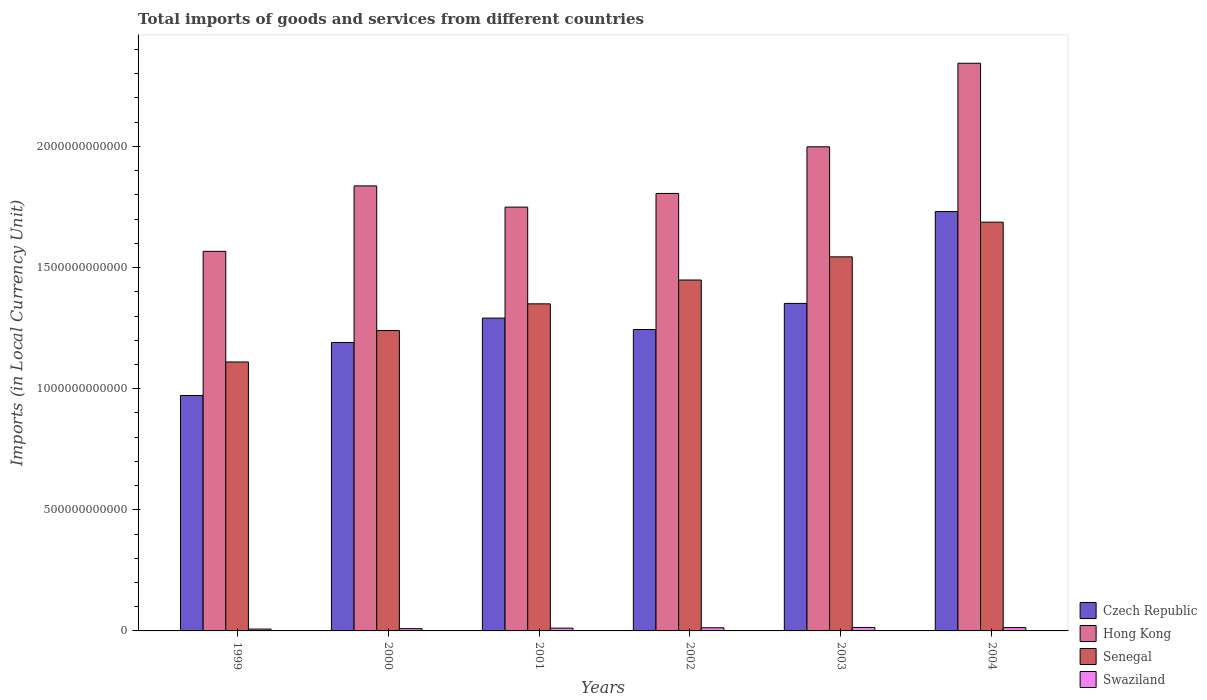How many groups of bars are there?
Your answer should be very brief. 6. Are the number of bars on each tick of the X-axis equal?
Provide a succinct answer. Yes. How many bars are there on the 3rd tick from the left?
Your answer should be very brief. 4. What is the label of the 6th group of bars from the left?
Provide a short and direct response. 2004. What is the Amount of goods and services imports in Czech Republic in 2004?
Provide a short and direct response. 1.73e+12. Across all years, what is the maximum Amount of goods and services imports in Czech Republic?
Keep it short and to the point. 1.73e+12. Across all years, what is the minimum Amount of goods and services imports in Swaziland?
Your answer should be very brief. 7.69e+09. In which year was the Amount of goods and services imports in Senegal minimum?
Make the answer very short. 1999. What is the total Amount of goods and services imports in Czech Republic in the graph?
Make the answer very short. 7.78e+12. What is the difference between the Amount of goods and services imports in Swaziland in 2002 and that in 2003?
Offer a very short reply. -1.25e+09. What is the difference between the Amount of goods and services imports in Senegal in 2000 and the Amount of goods and services imports in Hong Kong in 2002?
Provide a succinct answer. -5.66e+11. What is the average Amount of goods and services imports in Swaziland per year?
Your answer should be very brief. 1.16e+1. In the year 1999, what is the difference between the Amount of goods and services imports in Senegal and Amount of goods and services imports in Czech Republic?
Your response must be concise. 1.38e+11. In how many years, is the Amount of goods and services imports in Swaziland greater than 1100000000000 LCU?
Offer a very short reply. 0. What is the ratio of the Amount of goods and services imports in Swaziland in 2000 to that in 2004?
Your response must be concise. 0.68. What is the difference between the highest and the second highest Amount of goods and services imports in Swaziland?
Your answer should be very brief. 6.15e+08. What is the difference between the highest and the lowest Amount of goods and services imports in Senegal?
Give a very brief answer. 5.77e+11. In how many years, is the Amount of goods and services imports in Czech Republic greater than the average Amount of goods and services imports in Czech Republic taken over all years?
Your response must be concise. 2. Is the sum of the Amount of goods and services imports in Senegal in 1999 and 2002 greater than the maximum Amount of goods and services imports in Czech Republic across all years?
Offer a very short reply. Yes. What does the 1st bar from the left in 2001 represents?
Your response must be concise. Czech Republic. What does the 3rd bar from the right in 2003 represents?
Your answer should be compact. Hong Kong. How many bars are there?
Your answer should be very brief. 24. What is the difference between two consecutive major ticks on the Y-axis?
Provide a succinct answer. 5.00e+11. Are the values on the major ticks of Y-axis written in scientific E-notation?
Your response must be concise. No. How many legend labels are there?
Your answer should be compact. 4. How are the legend labels stacked?
Make the answer very short. Vertical. What is the title of the graph?
Offer a very short reply. Total imports of goods and services from different countries. What is the label or title of the X-axis?
Your answer should be compact. Years. What is the label or title of the Y-axis?
Make the answer very short. Imports (in Local Currency Unit). What is the Imports (in Local Currency Unit) of Czech Republic in 1999?
Ensure brevity in your answer.  9.72e+11. What is the Imports (in Local Currency Unit) of Hong Kong in 1999?
Offer a very short reply. 1.57e+12. What is the Imports (in Local Currency Unit) of Senegal in 1999?
Offer a very short reply. 1.11e+12. What is the Imports (in Local Currency Unit) in Swaziland in 1999?
Provide a succinct answer. 7.69e+09. What is the Imports (in Local Currency Unit) of Czech Republic in 2000?
Provide a short and direct response. 1.19e+12. What is the Imports (in Local Currency Unit) of Hong Kong in 2000?
Your answer should be compact. 1.84e+12. What is the Imports (in Local Currency Unit) of Senegal in 2000?
Provide a short and direct response. 1.24e+12. What is the Imports (in Local Currency Unit) in Swaziland in 2000?
Give a very brief answer. 9.31e+09. What is the Imports (in Local Currency Unit) of Czech Republic in 2001?
Make the answer very short. 1.29e+12. What is the Imports (in Local Currency Unit) of Hong Kong in 2001?
Offer a very short reply. 1.75e+12. What is the Imports (in Local Currency Unit) of Senegal in 2001?
Offer a very short reply. 1.35e+12. What is the Imports (in Local Currency Unit) of Swaziland in 2001?
Provide a succinct answer. 1.14e+1. What is the Imports (in Local Currency Unit) of Czech Republic in 2002?
Ensure brevity in your answer.  1.24e+12. What is the Imports (in Local Currency Unit) of Hong Kong in 2002?
Your response must be concise. 1.81e+12. What is the Imports (in Local Currency Unit) in Senegal in 2002?
Make the answer very short. 1.45e+12. What is the Imports (in Local Currency Unit) of Swaziland in 2002?
Make the answer very short. 1.30e+1. What is the Imports (in Local Currency Unit) of Czech Republic in 2003?
Give a very brief answer. 1.35e+12. What is the Imports (in Local Currency Unit) of Hong Kong in 2003?
Your answer should be compact. 2.00e+12. What is the Imports (in Local Currency Unit) of Senegal in 2003?
Provide a short and direct response. 1.54e+12. What is the Imports (in Local Currency Unit) in Swaziland in 2003?
Your answer should be compact. 1.43e+1. What is the Imports (in Local Currency Unit) of Czech Republic in 2004?
Offer a terse response. 1.73e+12. What is the Imports (in Local Currency Unit) in Hong Kong in 2004?
Provide a short and direct response. 2.34e+12. What is the Imports (in Local Currency Unit) in Senegal in 2004?
Provide a short and direct response. 1.69e+12. What is the Imports (in Local Currency Unit) in Swaziland in 2004?
Offer a terse response. 1.37e+1. Across all years, what is the maximum Imports (in Local Currency Unit) in Czech Republic?
Offer a very short reply. 1.73e+12. Across all years, what is the maximum Imports (in Local Currency Unit) of Hong Kong?
Offer a terse response. 2.34e+12. Across all years, what is the maximum Imports (in Local Currency Unit) in Senegal?
Ensure brevity in your answer.  1.69e+12. Across all years, what is the maximum Imports (in Local Currency Unit) of Swaziland?
Your answer should be compact. 1.43e+1. Across all years, what is the minimum Imports (in Local Currency Unit) in Czech Republic?
Keep it short and to the point. 9.72e+11. Across all years, what is the minimum Imports (in Local Currency Unit) in Hong Kong?
Your answer should be compact. 1.57e+12. Across all years, what is the minimum Imports (in Local Currency Unit) in Senegal?
Your response must be concise. 1.11e+12. Across all years, what is the minimum Imports (in Local Currency Unit) in Swaziland?
Keep it short and to the point. 7.69e+09. What is the total Imports (in Local Currency Unit) of Czech Republic in the graph?
Make the answer very short. 7.78e+12. What is the total Imports (in Local Currency Unit) in Hong Kong in the graph?
Ensure brevity in your answer.  1.13e+13. What is the total Imports (in Local Currency Unit) in Senegal in the graph?
Provide a short and direct response. 8.38e+12. What is the total Imports (in Local Currency Unit) of Swaziland in the graph?
Make the answer very short. 6.94e+1. What is the difference between the Imports (in Local Currency Unit) in Czech Republic in 1999 and that in 2000?
Ensure brevity in your answer.  -2.19e+11. What is the difference between the Imports (in Local Currency Unit) of Hong Kong in 1999 and that in 2000?
Your response must be concise. -2.70e+11. What is the difference between the Imports (in Local Currency Unit) of Senegal in 1999 and that in 2000?
Provide a succinct answer. -1.30e+11. What is the difference between the Imports (in Local Currency Unit) of Swaziland in 1999 and that in 2000?
Give a very brief answer. -1.63e+09. What is the difference between the Imports (in Local Currency Unit) of Czech Republic in 1999 and that in 2001?
Provide a short and direct response. -3.20e+11. What is the difference between the Imports (in Local Currency Unit) in Hong Kong in 1999 and that in 2001?
Provide a succinct answer. -1.83e+11. What is the difference between the Imports (in Local Currency Unit) of Senegal in 1999 and that in 2001?
Your response must be concise. -2.40e+11. What is the difference between the Imports (in Local Currency Unit) of Swaziland in 1999 and that in 2001?
Your answer should be very brief. -3.75e+09. What is the difference between the Imports (in Local Currency Unit) of Czech Republic in 1999 and that in 2002?
Offer a very short reply. -2.72e+11. What is the difference between the Imports (in Local Currency Unit) of Hong Kong in 1999 and that in 2002?
Give a very brief answer. -2.39e+11. What is the difference between the Imports (in Local Currency Unit) of Senegal in 1999 and that in 2002?
Offer a very short reply. -3.38e+11. What is the difference between the Imports (in Local Currency Unit) in Swaziland in 1999 and that in 2002?
Keep it short and to the point. -5.35e+09. What is the difference between the Imports (in Local Currency Unit) in Czech Republic in 1999 and that in 2003?
Offer a very short reply. -3.80e+11. What is the difference between the Imports (in Local Currency Unit) in Hong Kong in 1999 and that in 2003?
Make the answer very short. -4.32e+11. What is the difference between the Imports (in Local Currency Unit) of Senegal in 1999 and that in 2003?
Keep it short and to the point. -4.34e+11. What is the difference between the Imports (in Local Currency Unit) in Swaziland in 1999 and that in 2003?
Ensure brevity in your answer.  -6.61e+09. What is the difference between the Imports (in Local Currency Unit) of Czech Republic in 1999 and that in 2004?
Offer a very short reply. -7.59e+11. What is the difference between the Imports (in Local Currency Unit) in Hong Kong in 1999 and that in 2004?
Provide a short and direct response. -7.76e+11. What is the difference between the Imports (in Local Currency Unit) in Senegal in 1999 and that in 2004?
Ensure brevity in your answer.  -5.77e+11. What is the difference between the Imports (in Local Currency Unit) of Swaziland in 1999 and that in 2004?
Ensure brevity in your answer.  -5.99e+09. What is the difference between the Imports (in Local Currency Unit) in Czech Republic in 2000 and that in 2001?
Give a very brief answer. -1.01e+11. What is the difference between the Imports (in Local Currency Unit) of Hong Kong in 2000 and that in 2001?
Keep it short and to the point. 8.75e+1. What is the difference between the Imports (in Local Currency Unit) of Senegal in 2000 and that in 2001?
Offer a terse response. -1.10e+11. What is the difference between the Imports (in Local Currency Unit) in Swaziland in 2000 and that in 2001?
Provide a short and direct response. -2.13e+09. What is the difference between the Imports (in Local Currency Unit) of Czech Republic in 2000 and that in 2002?
Keep it short and to the point. -5.37e+1. What is the difference between the Imports (in Local Currency Unit) in Hong Kong in 2000 and that in 2002?
Provide a succinct answer. 3.12e+1. What is the difference between the Imports (in Local Currency Unit) of Senegal in 2000 and that in 2002?
Offer a very short reply. -2.09e+11. What is the difference between the Imports (in Local Currency Unit) of Swaziland in 2000 and that in 2002?
Provide a short and direct response. -3.73e+09. What is the difference between the Imports (in Local Currency Unit) of Czech Republic in 2000 and that in 2003?
Offer a terse response. -1.61e+11. What is the difference between the Imports (in Local Currency Unit) in Hong Kong in 2000 and that in 2003?
Your answer should be compact. -1.61e+11. What is the difference between the Imports (in Local Currency Unit) of Senegal in 2000 and that in 2003?
Provide a succinct answer. -3.04e+11. What is the difference between the Imports (in Local Currency Unit) in Swaziland in 2000 and that in 2003?
Keep it short and to the point. -4.98e+09. What is the difference between the Imports (in Local Currency Unit) of Czech Republic in 2000 and that in 2004?
Ensure brevity in your answer.  -5.40e+11. What is the difference between the Imports (in Local Currency Unit) in Hong Kong in 2000 and that in 2004?
Give a very brief answer. -5.06e+11. What is the difference between the Imports (in Local Currency Unit) of Senegal in 2000 and that in 2004?
Offer a very short reply. -4.47e+11. What is the difference between the Imports (in Local Currency Unit) in Swaziland in 2000 and that in 2004?
Make the answer very short. -4.37e+09. What is the difference between the Imports (in Local Currency Unit) in Czech Republic in 2001 and that in 2002?
Provide a short and direct response. 4.71e+1. What is the difference between the Imports (in Local Currency Unit) of Hong Kong in 2001 and that in 2002?
Give a very brief answer. -5.64e+1. What is the difference between the Imports (in Local Currency Unit) in Senegal in 2001 and that in 2002?
Ensure brevity in your answer.  -9.83e+1. What is the difference between the Imports (in Local Currency Unit) in Swaziland in 2001 and that in 2002?
Your answer should be very brief. -1.60e+09. What is the difference between the Imports (in Local Currency Unit) in Czech Republic in 2001 and that in 2003?
Provide a short and direct response. -6.06e+1. What is the difference between the Imports (in Local Currency Unit) of Hong Kong in 2001 and that in 2003?
Make the answer very short. -2.49e+11. What is the difference between the Imports (in Local Currency Unit) in Senegal in 2001 and that in 2003?
Make the answer very short. -1.94e+11. What is the difference between the Imports (in Local Currency Unit) in Swaziland in 2001 and that in 2003?
Your response must be concise. -2.85e+09. What is the difference between the Imports (in Local Currency Unit) in Czech Republic in 2001 and that in 2004?
Make the answer very short. -4.40e+11. What is the difference between the Imports (in Local Currency Unit) in Hong Kong in 2001 and that in 2004?
Offer a very short reply. -5.94e+11. What is the difference between the Imports (in Local Currency Unit) in Senegal in 2001 and that in 2004?
Keep it short and to the point. -3.37e+11. What is the difference between the Imports (in Local Currency Unit) in Swaziland in 2001 and that in 2004?
Your answer should be compact. -2.24e+09. What is the difference between the Imports (in Local Currency Unit) in Czech Republic in 2002 and that in 2003?
Your answer should be compact. -1.08e+11. What is the difference between the Imports (in Local Currency Unit) of Hong Kong in 2002 and that in 2003?
Provide a succinct answer. -1.93e+11. What is the difference between the Imports (in Local Currency Unit) in Senegal in 2002 and that in 2003?
Your answer should be very brief. -9.56e+1. What is the difference between the Imports (in Local Currency Unit) of Swaziland in 2002 and that in 2003?
Make the answer very short. -1.25e+09. What is the difference between the Imports (in Local Currency Unit) in Czech Republic in 2002 and that in 2004?
Provide a succinct answer. -4.87e+11. What is the difference between the Imports (in Local Currency Unit) of Hong Kong in 2002 and that in 2004?
Your answer should be compact. -5.37e+11. What is the difference between the Imports (in Local Currency Unit) in Senegal in 2002 and that in 2004?
Your answer should be compact. -2.39e+11. What is the difference between the Imports (in Local Currency Unit) of Swaziland in 2002 and that in 2004?
Make the answer very short. -6.40e+08. What is the difference between the Imports (in Local Currency Unit) in Czech Republic in 2003 and that in 2004?
Your answer should be compact. -3.79e+11. What is the difference between the Imports (in Local Currency Unit) in Hong Kong in 2003 and that in 2004?
Make the answer very short. -3.45e+11. What is the difference between the Imports (in Local Currency Unit) in Senegal in 2003 and that in 2004?
Offer a very short reply. -1.43e+11. What is the difference between the Imports (in Local Currency Unit) of Swaziland in 2003 and that in 2004?
Keep it short and to the point. 6.15e+08. What is the difference between the Imports (in Local Currency Unit) in Czech Republic in 1999 and the Imports (in Local Currency Unit) in Hong Kong in 2000?
Your answer should be compact. -8.65e+11. What is the difference between the Imports (in Local Currency Unit) in Czech Republic in 1999 and the Imports (in Local Currency Unit) in Senegal in 2000?
Keep it short and to the point. -2.68e+11. What is the difference between the Imports (in Local Currency Unit) in Czech Republic in 1999 and the Imports (in Local Currency Unit) in Swaziland in 2000?
Offer a terse response. 9.63e+11. What is the difference between the Imports (in Local Currency Unit) of Hong Kong in 1999 and the Imports (in Local Currency Unit) of Senegal in 2000?
Make the answer very short. 3.27e+11. What is the difference between the Imports (in Local Currency Unit) in Hong Kong in 1999 and the Imports (in Local Currency Unit) in Swaziland in 2000?
Your answer should be compact. 1.56e+12. What is the difference between the Imports (in Local Currency Unit) in Senegal in 1999 and the Imports (in Local Currency Unit) in Swaziland in 2000?
Your answer should be compact. 1.10e+12. What is the difference between the Imports (in Local Currency Unit) of Czech Republic in 1999 and the Imports (in Local Currency Unit) of Hong Kong in 2001?
Provide a succinct answer. -7.78e+11. What is the difference between the Imports (in Local Currency Unit) of Czech Republic in 1999 and the Imports (in Local Currency Unit) of Senegal in 2001?
Provide a succinct answer. -3.78e+11. What is the difference between the Imports (in Local Currency Unit) of Czech Republic in 1999 and the Imports (in Local Currency Unit) of Swaziland in 2001?
Keep it short and to the point. 9.60e+11. What is the difference between the Imports (in Local Currency Unit) of Hong Kong in 1999 and the Imports (in Local Currency Unit) of Senegal in 2001?
Make the answer very short. 2.17e+11. What is the difference between the Imports (in Local Currency Unit) of Hong Kong in 1999 and the Imports (in Local Currency Unit) of Swaziland in 2001?
Provide a short and direct response. 1.56e+12. What is the difference between the Imports (in Local Currency Unit) in Senegal in 1999 and the Imports (in Local Currency Unit) in Swaziland in 2001?
Provide a short and direct response. 1.10e+12. What is the difference between the Imports (in Local Currency Unit) in Czech Republic in 1999 and the Imports (in Local Currency Unit) in Hong Kong in 2002?
Ensure brevity in your answer.  -8.34e+11. What is the difference between the Imports (in Local Currency Unit) of Czech Republic in 1999 and the Imports (in Local Currency Unit) of Senegal in 2002?
Your answer should be very brief. -4.77e+11. What is the difference between the Imports (in Local Currency Unit) of Czech Republic in 1999 and the Imports (in Local Currency Unit) of Swaziland in 2002?
Your answer should be compact. 9.59e+11. What is the difference between the Imports (in Local Currency Unit) in Hong Kong in 1999 and the Imports (in Local Currency Unit) in Senegal in 2002?
Your answer should be compact. 1.18e+11. What is the difference between the Imports (in Local Currency Unit) in Hong Kong in 1999 and the Imports (in Local Currency Unit) in Swaziland in 2002?
Provide a succinct answer. 1.55e+12. What is the difference between the Imports (in Local Currency Unit) in Senegal in 1999 and the Imports (in Local Currency Unit) in Swaziland in 2002?
Your response must be concise. 1.10e+12. What is the difference between the Imports (in Local Currency Unit) in Czech Republic in 1999 and the Imports (in Local Currency Unit) in Hong Kong in 2003?
Provide a succinct answer. -1.03e+12. What is the difference between the Imports (in Local Currency Unit) in Czech Republic in 1999 and the Imports (in Local Currency Unit) in Senegal in 2003?
Ensure brevity in your answer.  -5.72e+11. What is the difference between the Imports (in Local Currency Unit) of Czech Republic in 1999 and the Imports (in Local Currency Unit) of Swaziland in 2003?
Provide a short and direct response. 9.58e+11. What is the difference between the Imports (in Local Currency Unit) of Hong Kong in 1999 and the Imports (in Local Currency Unit) of Senegal in 2003?
Offer a terse response. 2.28e+1. What is the difference between the Imports (in Local Currency Unit) in Hong Kong in 1999 and the Imports (in Local Currency Unit) in Swaziland in 2003?
Your answer should be very brief. 1.55e+12. What is the difference between the Imports (in Local Currency Unit) in Senegal in 1999 and the Imports (in Local Currency Unit) in Swaziland in 2003?
Make the answer very short. 1.10e+12. What is the difference between the Imports (in Local Currency Unit) in Czech Republic in 1999 and the Imports (in Local Currency Unit) in Hong Kong in 2004?
Give a very brief answer. -1.37e+12. What is the difference between the Imports (in Local Currency Unit) in Czech Republic in 1999 and the Imports (in Local Currency Unit) in Senegal in 2004?
Offer a terse response. -7.15e+11. What is the difference between the Imports (in Local Currency Unit) of Czech Republic in 1999 and the Imports (in Local Currency Unit) of Swaziland in 2004?
Your answer should be very brief. 9.58e+11. What is the difference between the Imports (in Local Currency Unit) of Hong Kong in 1999 and the Imports (in Local Currency Unit) of Senegal in 2004?
Give a very brief answer. -1.20e+11. What is the difference between the Imports (in Local Currency Unit) in Hong Kong in 1999 and the Imports (in Local Currency Unit) in Swaziland in 2004?
Make the answer very short. 1.55e+12. What is the difference between the Imports (in Local Currency Unit) of Senegal in 1999 and the Imports (in Local Currency Unit) of Swaziland in 2004?
Ensure brevity in your answer.  1.10e+12. What is the difference between the Imports (in Local Currency Unit) in Czech Republic in 2000 and the Imports (in Local Currency Unit) in Hong Kong in 2001?
Provide a short and direct response. -5.59e+11. What is the difference between the Imports (in Local Currency Unit) in Czech Republic in 2000 and the Imports (in Local Currency Unit) in Senegal in 2001?
Provide a short and direct response. -1.60e+11. What is the difference between the Imports (in Local Currency Unit) in Czech Republic in 2000 and the Imports (in Local Currency Unit) in Swaziland in 2001?
Your answer should be compact. 1.18e+12. What is the difference between the Imports (in Local Currency Unit) in Hong Kong in 2000 and the Imports (in Local Currency Unit) in Senegal in 2001?
Offer a terse response. 4.87e+11. What is the difference between the Imports (in Local Currency Unit) of Hong Kong in 2000 and the Imports (in Local Currency Unit) of Swaziland in 2001?
Your response must be concise. 1.83e+12. What is the difference between the Imports (in Local Currency Unit) of Senegal in 2000 and the Imports (in Local Currency Unit) of Swaziland in 2001?
Your answer should be compact. 1.23e+12. What is the difference between the Imports (in Local Currency Unit) in Czech Republic in 2000 and the Imports (in Local Currency Unit) in Hong Kong in 2002?
Offer a very short reply. -6.15e+11. What is the difference between the Imports (in Local Currency Unit) in Czech Republic in 2000 and the Imports (in Local Currency Unit) in Senegal in 2002?
Your answer should be compact. -2.58e+11. What is the difference between the Imports (in Local Currency Unit) in Czech Republic in 2000 and the Imports (in Local Currency Unit) in Swaziland in 2002?
Your answer should be compact. 1.18e+12. What is the difference between the Imports (in Local Currency Unit) of Hong Kong in 2000 and the Imports (in Local Currency Unit) of Senegal in 2002?
Provide a succinct answer. 3.89e+11. What is the difference between the Imports (in Local Currency Unit) of Hong Kong in 2000 and the Imports (in Local Currency Unit) of Swaziland in 2002?
Provide a short and direct response. 1.82e+12. What is the difference between the Imports (in Local Currency Unit) in Senegal in 2000 and the Imports (in Local Currency Unit) in Swaziland in 2002?
Ensure brevity in your answer.  1.23e+12. What is the difference between the Imports (in Local Currency Unit) of Czech Republic in 2000 and the Imports (in Local Currency Unit) of Hong Kong in 2003?
Your answer should be compact. -8.08e+11. What is the difference between the Imports (in Local Currency Unit) of Czech Republic in 2000 and the Imports (in Local Currency Unit) of Senegal in 2003?
Offer a terse response. -3.54e+11. What is the difference between the Imports (in Local Currency Unit) in Czech Republic in 2000 and the Imports (in Local Currency Unit) in Swaziland in 2003?
Your answer should be very brief. 1.18e+12. What is the difference between the Imports (in Local Currency Unit) in Hong Kong in 2000 and the Imports (in Local Currency Unit) in Senegal in 2003?
Your answer should be very brief. 2.93e+11. What is the difference between the Imports (in Local Currency Unit) in Hong Kong in 2000 and the Imports (in Local Currency Unit) in Swaziland in 2003?
Keep it short and to the point. 1.82e+12. What is the difference between the Imports (in Local Currency Unit) in Senegal in 2000 and the Imports (in Local Currency Unit) in Swaziland in 2003?
Make the answer very short. 1.23e+12. What is the difference between the Imports (in Local Currency Unit) in Czech Republic in 2000 and the Imports (in Local Currency Unit) in Hong Kong in 2004?
Your answer should be very brief. -1.15e+12. What is the difference between the Imports (in Local Currency Unit) of Czech Republic in 2000 and the Imports (in Local Currency Unit) of Senegal in 2004?
Your response must be concise. -4.97e+11. What is the difference between the Imports (in Local Currency Unit) of Czech Republic in 2000 and the Imports (in Local Currency Unit) of Swaziland in 2004?
Provide a short and direct response. 1.18e+12. What is the difference between the Imports (in Local Currency Unit) of Hong Kong in 2000 and the Imports (in Local Currency Unit) of Senegal in 2004?
Your answer should be very brief. 1.50e+11. What is the difference between the Imports (in Local Currency Unit) of Hong Kong in 2000 and the Imports (in Local Currency Unit) of Swaziland in 2004?
Provide a short and direct response. 1.82e+12. What is the difference between the Imports (in Local Currency Unit) in Senegal in 2000 and the Imports (in Local Currency Unit) in Swaziland in 2004?
Keep it short and to the point. 1.23e+12. What is the difference between the Imports (in Local Currency Unit) in Czech Republic in 2001 and the Imports (in Local Currency Unit) in Hong Kong in 2002?
Your response must be concise. -5.15e+11. What is the difference between the Imports (in Local Currency Unit) of Czech Republic in 2001 and the Imports (in Local Currency Unit) of Senegal in 2002?
Make the answer very short. -1.57e+11. What is the difference between the Imports (in Local Currency Unit) of Czech Republic in 2001 and the Imports (in Local Currency Unit) of Swaziland in 2002?
Give a very brief answer. 1.28e+12. What is the difference between the Imports (in Local Currency Unit) of Hong Kong in 2001 and the Imports (in Local Currency Unit) of Senegal in 2002?
Give a very brief answer. 3.01e+11. What is the difference between the Imports (in Local Currency Unit) in Hong Kong in 2001 and the Imports (in Local Currency Unit) in Swaziland in 2002?
Provide a succinct answer. 1.74e+12. What is the difference between the Imports (in Local Currency Unit) of Senegal in 2001 and the Imports (in Local Currency Unit) of Swaziland in 2002?
Give a very brief answer. 1.34e+12. What is the difference between the Imports (in Local Currency Unit) of Czech Republic in 2001 and the Imports (in Local Currency Unit) of Hong Kong in 2003?
Offer a terse response. -7.07e+11. What is the difference between the Imports (in Local Currency Unit) in Czech Republic in 2001 and the Imports (in Local Currency Unit) in Senegal in 2003?
Provide a short and direct response. -2.53e+11. What is the difference between the Imports (in Local Currency Unit) of Czech Republic in 2001 and the Imports (in Local Currency Unit) of Swaziland in 2003?
Make the answer very short. 1.28e+12. What is the difference between the Imports (in Local Currency Unit) of Hong Kong in 2001 and the Imports (in Local Currency Unit) of Senegal in 2003?
Make the answer very short. 2.05e+11. What is the difference between the Imports (in Local Currency Unit) of Hong Kong in 2001 and the Imports (in Local Currency Unit) of Swaziland in 2003?
Provide a short and direct response. 1.74e+12. What is the difference between the Imports (in Local Currency Unit) in Senegal in 2001 and the Imports (in Local Currency Unit) in Swaziland in 2003?
Your response must be concise. 1.34e+12. What is the difference between the Imports (in Local Currency Unit) in Czech Republic in 2001 and the Imports (in Local Currency Unit) in Hong Kong in 2004?
Your answer should be very brief. -1.05e+12. What is the difference between the Imports (in Local Currency Unit) in Czech Republic in 2001 and the Imports (in Local Currency Unit) in Senegal in 2004?
Your response must be concise. -3.96e+11. What is the difference between the Imports (in Local Currency Unit) of Czech Republic in 2001 and the Imports (in Local Currency Unit) of Swaziland in 2004?
Make the answer very short. 1.28e+12. What is the difference between the Imports (in Local Currency Unit) in Hong Kong in 2001 and the Imports (in Local Currency Unit) in Senegal in 2004?
Provide a succinct answer. 6.23e+1. What is the difference between the Imports (in Local Currency Unit) in Hong Kong in 2001 and the Imports (in Local Currency Unit) in Swaziland in 2004?
Offer a terse response. 1.74e+12. What is the difference between the Imports (in Local Currency Unit) in Senegal in 2001 and the Imports (in Local Currency Unit) in Swaziland in 2004?
Provide a succinct answer. 1.34e+12. What is the difference between the Imports (in Local Currency Unit) in Czech Republic in 2002 and the Imports (in Local Currency Unit) in Hong Kong in 2003?
Offer a very short reply. -7.54e+11. What is the difference between the Imports (in Local Currency Unit) in Czech Republic in 2002 and the Imports (in Local Currency Unit) in Senegal in 2003?
Your response must be concise. -3.00e+11. What is the difference between the Imports (in Local Currency Unit) in Czech Republic in 2002 and the Imports (in Local Currency Unit) in Swaziland in 2003?
Your answer should be compact. 1.23e+12. What is the difference between the Imports (in Local Currency Unit) in Hong Kong in 2002 and the Imports (in Local Currency Unit) in Senegal in 2003?
Ensure brevity in your answer.  2.62e+11. What is the difference between the Imports (in Local Currency Unit) of Hong Kong in 2002 and the Imports (in Local Currency Unit) of Swaziland in 2003?
Your response must be concise. 1.79e+12. What is the difference between the Imports (in Local Currency Unit) in Senegal in 2002 and the Imports (in Local Currency Unit) in Swaziland in 2003?
Make the answer very short. 1.43e+12. What is the difference between the Imports (in Local Currency Unit) in Czech Republic in 2002 and the Imports (in Local Currency Unit) in Hong Kong in 2004?
Provide a succinct answer. -1.10e+12. What is the difference between the Imports (in Local Currency Unit) in Czech Republic in 2002 and the Imports (in Local Currency Unit) in Senegal in 2004?
Your response must be concise. -4.43e+11. What is the difference between the Imports (in Local Currency Unit) of Czech Republic in 2002 and the Imports (in Local Currency Unit) of Swaziland in 2004?
Your response must be concise. 1.23e+12. What is the difference between the Imports (in Local Currency Unit) of Hong Kong in 2002 and the Imports (in Local Currency Unit) of Senegal in 2004?
Make the answer very short. 1.19e+11. What is the difference between the Imports (in Local Currency Unit) of Hong Kong in 2002 and the Imports (in Local Currency Unit) of Swaziland in 2004?
Make the answer very short. 1.79e+12. What is the difference between the Imports (in Local Currency Unit) in Senegal in 2002 and the Imports (in Local Currency Unit) in Swaziland in 2004?
Your response must be concise. 1.43e+12. What is the difference between the Imports (in Local Currency Unit) of Czech Republic in 2003 and the Imports (in Local Currency Unit) of Hong Kong in 2004?
Ensure brevity in your answer.  -9.91e+11. What is the difference between the Imports (in Local Currency Unit) of Czech Republic in 2003 and the Imports (in Local Currency Unit) of Senegal in 2004?
Provide a succinct answer. -3.35e+11. What is the difference between the Imports (in Local Currency Unit) in Czech Republic in 2003 and the Imports (in Local Currency Unit) in Swaziland in 2004?
Your answer should be very brief. 1.34e+12. What is the difference between the Imports (in Local Currency Unit) in Hong Kong in 2003 and the Imports (in Local Currency Unit) in Senegal in 2004?
Ensure brevity in your answer.  3.11e+11. What is the difference between the Imports (in Local Currency Unit) in Hong Kong in 2003 and the Imports (in Local Currency Unit) in Swaziland in 2004?
Provide a short and direct response. 1.98e+12. What is the difference between the Imports (in Local Currency Unit) in Senegal in 2003 and the Imports (in Local Currency Unit) in Swaziland in 2004?
Give a very brief answer. 1.53e+12. What is the average Imports (in Local Currency Unit) of Czech Republic per year?
Offer a very short reply. 1.30e+12. What is the average Imports (in Local Currency Unit) in Hong Kong per year?
Your answer should be compact. 1.88e+12. What is the average Imports (in Local Currency Unit) of Senegal per year?
Your response must be concise. 1.40e+12. What is the average Imports (in Local Currency Unit) in Swaziland per year?
Provide a succinct answer. 1.16e+1. In the year 1999, what is the difference between the Imports (in Local Currency Unit) in Czech Republic and Imports (in Local Currency Unit) in Hong Kong?
Offer a terse response. -5.95e+11. In the year 1999, what is the difference between the Imports (in Local Currency Unit) of Czech Republic and Imports (in Local Currency Unit) of Senegal?
Your response must be concise. -1.38e+11. In the year 1999, what is the difference between the Imports (in Local Currency Unit) in Czech Republic and Imports (in Local Currency Unit) in Swaziland?
Make the answer very short. 9.64e+11. In the year 1999, what is the difference between the Imports (in Local Currency Unit) of Hong Kong and Imports (in Local Currency Unit) of Senegal?
Ensure brevity in your answer.  4.57e+11. In the year 1999, what is the difference between the Imports (in Local Currency Unit) of Hong Kong and Imports (in Local Currency Unit) of Swaziland?
Offer a terse response. 1.56e+12. In the year 1999, what is the difference between the Imports (in Local Currency Unit) in Senegal and Imports (in Local Currency Unit) in Swaziland?
Ensure brevity in your answer.  1.10e+12. In the year 2000, what is the difference between the Imports (in Local Currency Unit) of Czech Republic and Imports (in Local Currency Unit) of Hong Kong?
Offer a terse response. -6.46e+11. In the year 2000, what is the difference between the Imports (in Local Currency Unit) of Czech Republic and Imports (in Local Currency Unit) of Senegal?
Your answer should be very brief. -4.93e+1. In the year 2000, what is the difference between the Imports (in Local Currency Unit) of Czech Republic and Imports (in Local Currency Unit) of Swaziland?
Ensure brevity in your answer.  1.18e+12. In the year 2000, what is the difference between the Imports (in Local Currency Unit) in Hong Kong and Imports (in Local Currency Unit) in Senegal?
Keep it short and to the point. 5.97e+11. In the year 2000, what is the difference between the Imports (in Local Currency Unit) in Hong Kong and Imports (in Local Currency Unit) in Swaziland?
Provide a short and direct response. 1.83e+12. In the year 2000, what is the difference between the Imports (in Local Currency Unit) of Senegal and Imports (in Local Currency Unit) of Swaziland?
Your answer should be very brief. 1.23e+12. In the year 2001, what is the difference between the Imports (in Local Currency Unit) of Czech Republic and Imports (in Local Currency Unit) of Hong Kong?
Your response must be concise. -4.58e+11. In the year 2001, what is the difference between the Imports (in Local Currency Unit) of Czech Republic and Imports (in Local Currency Unit) of Senegal?
Your response must be concise. -5.89e+1. In the year 2001, what is the difference between the Imports (in Local Currency Unit) of Czech Republic and Imports (in Local Currency Unit) of Swaziland?
Give a very brief answer. 1.28e+12. In the year 2001, what is the difference between the Imports (in Local Currency Unit) of Hong Kong and Imports (in Local Currency Unit) of Senegal?
Your response must be concise. 3.99e+11. In the year 2001, what is the difference between the Imports (in Local Currency Unit) of Hong Kong and Imports (in Local Currency Unit) of Swaziland?
Offer a very short reply. 1.74e+12. In the year 2001, what is the difference between the Imports (in Local Currency Unit) in Senegal and Imports (in Local Currency Unit) in Swaziland?
Provide a short and direct response. 1.34e+12. In the year 2002, what is the difference between the Imports (in Local Currency Unit) of Czech Republic and Imports (in Local Currency Unit) of Hong Kong?
Your response must be concise. -5.62e+11. In the year 2002, what is the difference between the Imports (in Local Currency Unit) of Czech Republic and Imports (in Local Currency Unit) of Senegal?
Your response must be concise. -2.04e+11. In the year 2002, what is the difference between the Imports (in Local Currency Unit) in Czech Republic and Imports (in Local Currency Unit) in Swaziland?
Provide a short and direct response. 1.23e+12. In the year 2002, what is the difference between the Imports (in Local Currency Unit) of Hong Kong and Imports (in Local Currency Unit) of Senegal?
Your answer should be very brief. 3.57e+11. In the year 2002, what is the difference between the Imports (in Local Currency Unit) of Hong Kong and Imports (in Local Currency Unit) of Swaziland?
Keep it short and to the point. 1.79e+12. In the year 2002, what is the difference between the Imports (in Local Currency Unit) in Senegal and Imports (in Local Currency Unit) in Swaziland?
Offer a terse response. 1.44e+12. In the year 2003, what is the difference between the Imports (in Local Currency Unit) in Czech Republic and Imports (in Local Currency Unit) in Hong Kong?
Your answer should be compact. -6.47e+11. In the year 2003, what is the difference between the Imports (in Local Currency Unit) of Czech Republic and Imports (in Local Currency Unit) of Senegal?
Offer a terse response. -1.92e+11. In the year 2003, what is the difference between the Imports (in Local Currency Unit) of Czech Republic and Imports (in Local Currency Unit) of Swaziland?
Your answer should be very brief. 1.34e+12. In the year 2003, what is the difference between the Imports (in Local Currency Unit) in Hong Kong and Imports (in Local Currency Unit) in Senegal?
Give a very brief answer. 4.54e+11. In the year 2003, what is the difference between the Imports (in Local Currency Unit) of Hong Kong and Imports (in Local Currency Unit) of Swaziland?
Provide a succinct answer. 1.98e+12. In the year 2003, what is the difference between the Imports (in Local Currency Unit) of Senegal and Imports (in Local Currency Unit) of Swaziland?
Make the answer very short. 1.53e+12. In the year 2004, what is the difference between the Imports (in Local Currency Unit) in Czech Republic and Imports (in Local Currency Unit) in Hong Kong?
Give a very brief answer. -6.12e+11. In the year 2004, what is the difference between the Imports (in Local Currency Unit) in Czech Republic and Imports (in Local Currency Unit) in Senegal?
Keep it short and to the point. 4.38e+1. In the year 2004, what is the difference between the Imports (in Local Currency Unit) of Czech Republic and Imports (in Local Currency Unit) of Swaziland?
Provide a short and direct response. 1.72e+12. In the year 2004, what is the difference between the Imports (in Local Currency Unit) in Hong Kong and Imports (in Local Currency Unit) in Senegal?
Offer a terse response. 6.56e+11. In the year 2004, what is the difference between the Imports (in Local Currency Unit) of Hong Kong and Imports (in Local Currency Unit) of Swaziland?
Your answer should be compact. 2.33e+12. In the year 2004, what is the difference between the Imports (in Local Currency Unit) of Senegal and Imports (in Local Currency Unit) of Swaziland?
Keep it short and to the point. 1.67e+12. What is the ratio of the Imports (in Local Currency Unit) of Czech Republic in 1999 to that in 2000?
Give a very brief answer. 0.82. What is the ratio of the Imports (in Local Currency Unit) of Hong Kong in 1999 to that in 2000?
Your answer should be compact. 0.85. What is the ratio of the Imports (in Local Currency Unit) of Senegal in 1999 to that in 2000?
Ensure brevity in your answer.  0.9. What is the ratio of the Imports (in Local Currency Unit) in Swaziland in 1999 to that in 2000?
Make the answer very short. 0.83. What is the ratio of the Imports (in Local Currency Unit) in Czech Republic in 1999 to that in 2001?
Your answer should be compact. 0.75. What is the ratio of the Imports (in Local Currency Unit) of Hong Kong in 1999 to that in 2001?
Provide a succinct answer. 0.9. What is the ratio of the Imports (in Local Currency Unit) in Senegal in 1999 to that in 2001?
Ensure brevity in your answer.  0.82. What is the ratio of the Imports (in Local Currency Unit) of Swaziland in 1999 to that in 2001?
Offer a very short reply. 0.67. What is the ratio of the Imports (in Local Currency Unit) of Czech Republic in 1999 to that in 2002?
Your answer should be very brief. 0.78. What is the ratio of the Imports (in Local Currency Unit) of Hong Kong in 1999 to that in 2002?
Make the answer very short. 0.87. What is the ratio of the Imports (in Local Currency Unit) of Senegal in 1999 to that in 2002?
Provide a short and direct response. 0.77. What is the ratio of the Imports (in Local Currency Unit) in Swaziland in 1999 to that in 2002?
Make the answer very short. 0.59. What is the ratio of the Imports (in Local Currency Unit) in Czech Republic in 1999 to that in 2003?
Offer a terse response. 0.72. What is the ratio of the Imports (in Local Currency Unit) in Hong Kong in 1999 to that in 2003?
Your answer should be compact. 0.78. What is the ratio of the Imports (in Local Currency Unit) of Senegal in 1999 to that in 2003?
Ensure brevity in your answer.  0.72. What is the ratio of the Imports (in Local Currency Unit) in Swaziland in 1999 to that in 2003?
Offer a terse response. 0.54. What is the ratio of the Imports (in Local Currency Unit) in Czech Republic in 1999 to that in 2004?
Give a very brief answer. 0.56. What is the ratio of the Imports (in Local Currency Unit) in Hong Kong in 1999 to that in 2004?
Provide a short and direct response. 0.67. What is the ratio of the Imports (in Local Currency Unit) of Senegal in 1999 to that in 2004?
Your answer should be compact. 0.66. What is the ratio of the Imports (in Local Currency Unit) in Swaziland in 1999 to that in 2004?
Offer a terse response. 0.56. What is the ratio of the Imports (in Local Currency Unit) of Czech Republic in 2000 to that in 2001?
Give a very brief answer. 0.92. What is the ratio of the Imports (in Local Currency Unit) of Senegal in 2000 to that in 2001?
Provide a short and direct response. 0.92. What is the ratio of the Imports (in Local Currency Unit) in Swaziland in 2000 to that in 2001?
Give a very brief answer. 0.81. What is the ratio of the Imports (in Local Currency Unit) of Czech Republic in 2000 to that in 2002?
Your response must be concise. 0.96. What is the ratio of the Imports (in Local Currency Unit) of Hong Kong in 2000 to that in 2002?
Offer a very short reply. 1.02. What is the ratio of the Imports (in Local Currency Unit) in Senegal in 2000 to that in 2002?
Provide a short and direct response. 0.86. What is the ratio of the Imports (in Local Currency Unit) in Swaziland in 2000 to that in 2002?
Keep it short and to the point. 0.71. What is the ratio of the Imports (in Local Currency Unit) in Czech Republic in 2000 to that in 2003?
Keep it short and to the point. 0.88. What is the ratio of the Imports (in Local Currency Unit) of Hong Kong in 2000 to that in 2003?
Ensure brevity in your answer.  0.92. What is the ratio of the Imports (in Local Currency Unit) of Senegal in 2000 to that in 2003?
Give a very brief answer. 0.8. What is the ratio of the Imports (in Local Currency Unit) of Swaziland in 2000 to that in 2003?
Your answer should be very brief. 0.65. What is the ratio of the Imports (in Local Currency Unit) of Czech Republic in 2000 to that in 2004?
Your answer should be very brief. 0.69. What is the ratio of the Imports (in Local Currency Unit) in Hong Kong in 2000 to that in 2004?
Your response must be concise. 0.78. What is the ratio of the Imports (in Local Currency Unit) in Senegal in 2000 to that in 2004?
Give a very brief answer. 0.73. What is the ratio of the Imports (in Local Currency Unit) of Swaziland in 2000 to that in 2004?
Make the answer very short. 0.68. What is the ratio of the Imports (in Local Currency Unit) of Czech Republic in 2001 to that in 2002?
Your response must be concise. 1.04. What is the ratio of the Imports (in Local Currency Unit) of Hong Kong in 2001 to that in 2002?
Your answer should be very brief. 0.97. What is the ratio of the Imports (in Local Currency Unit) of Senegal in 2001 to that in 2002?
Offer a terse response. 0.93. What is the ratio of the Imports (in Local Currency Unit) in Swaziland in 2001 to that in 2002?
Your answer should be compact. 0.88. What is the ratio of the Imports (in Local Currency Unit) of Czech Republic in 2001 to that in 2003?
Make the answer very short. 0.96. What is the ratio of the Imports (in Local Currency Unit) of Hong Kong in 2001 to that in 2003?
Provide a short and direct response. 0.88. What is the ratio of the Imports (in Local Currency Unit) in Senegal in 2001 to that in 2003?
Your answer should be very brief. 0.87. What is the ratio of the Imports (in Local Currency Unit) of Swaziland in 2001 to that in 2003?
Your answer should be compact. 0.8. What is the ratio of the Imports (in Local Currency Unit) of Czech Republic in 2001 to that in 2004?
Make the answer very short. 0.75. What is the ratio of the Imports (in Local Currency Unit) in Hong Kong in 2001 to that in 2004?
Keep it short and to the point. 0.75. What is the ratio of the Imports (in Local Currency Unit) of Senegal in 2001 to that in 2004?
Your response must be concise. 0.8. What is the ratio of the Imports (in Local Currency Unit) in Swaziland in 2001 to that in 2004?
Your response must be concise. 0.84. What is the ratio of the Imports (in Local Currency Unit) of Czech Republic in 2002 to that in 2003?
Provide a short and direct response. 0.92. What is the ratio of the Imports (in Local Currency Unit) in Hong Kong in 2002 to that in 2003?
Offer a very short reply. 0.9. What is the ratio of the Imports (in Local Currency Unit) of Senegal in 2002 to that in 2003?
Offer a very short reply. 0.94. What is the ratio of the Imports (in Local Currency Unit) of Swaziland in 2002 to that in 2003?
Offer a terse response. 0.91. What is the ratio of the Imports (in Local Currency Unit) of Czech Republic in 2002 to that in 2004?
Provide a short and direct response. 0.72. What is the ratio of the Imports (in Local Currency Unit) of Hong Kong in 2002 to that in 2004?
Provide a succinct answer. 0.77. What is the ratio of the Imports (in Local Currency Unit) in Senegal in 2002 to that in 2004?
Your response must be concise. 0.86. What is the ratio of the Imports (in Local Currency Unit) of Swaziland in 2002 to that in 2004?
Keep it short and to the point. 0.95. What is the ratio of the Imports (in Local Currency Unit) in Czech Republic in 2003 to that in 2004?
Your response must be concise. 0.78. What is the ratio of the Imports (in Local Currency Unit) of Hong Kong in 2003 to that in 2004?
Offer a very short reply. 0.85. What is the ratio of the Imports (in Local Currency Unit) of Senegal in 2003 to that in 2004?
Your answer should be compact. 0.92. What is the ratio of the Imports (in Local Currency Unit) in Swaziland in 2003 to that in 2004?
Provide a succinct answer. 1.04. What is the difference between the highest and the second highest Imports (in Local Currency Unit) in Czech Republic?
Your answer should be compact. 3.79e+11. What is the difference between the highest and the second highest Imports (in Local Currency Unit) of Hong Kong?
Your answer should be very brief. 3.45e+11. What is the difference between the highest and the second highest Imports (in Local Currency Unit) of Senegal?
Offer a terse response. 1.43e+11. What is the difference between the highest and the second highest Imports (in Local Currency Unit) in Swaziland?
Your response must be concise. 6.15e+08. What is the difference between the highest and the lowest Imports (in Local Currency Unit) in Czech Republic?
Provide a succinct answer. 7.59e+11. What is the difference between the highest and the lowest Imports (in Local Currency Unit) of Hong Kong?
Provide a short and direct response. 7.76e+11. What is the difference between the highest and the lowest Imports (in Local Currency Unit) in Senegal?
Offer a very short reply. 5.77e+11. What is the difference between the highest and the lowest Imports (in Local Currency Unit) of Swaziland?
Make the answer very short. 6.61e+09. 